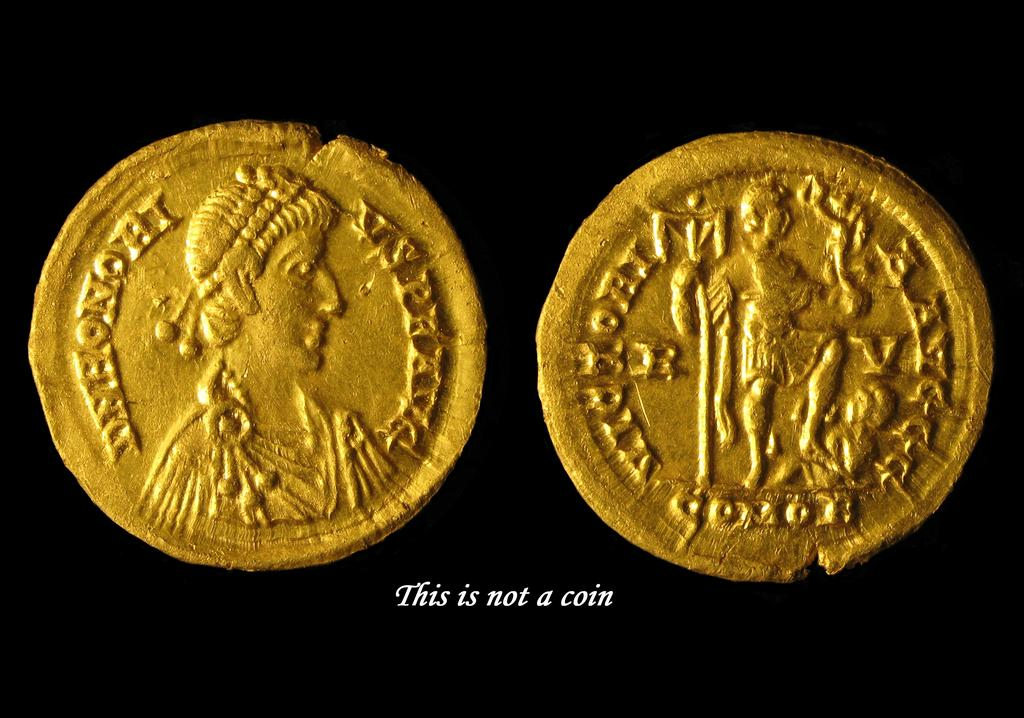<image>
Give a short and clear explanation of the subsequent image. A gold coin is captioned with a phrase saying that it's not a coin. 